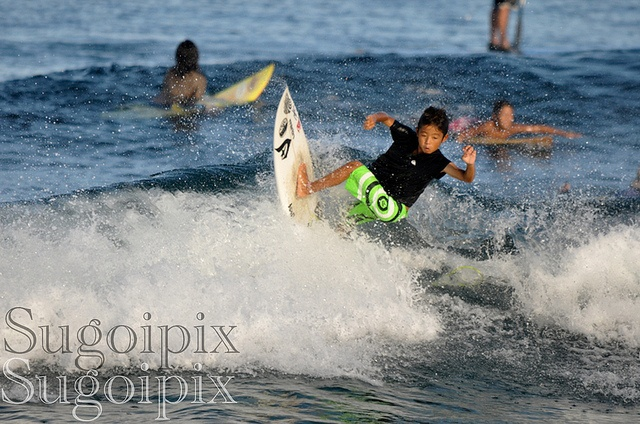Describe the objects in this image and their specific colors. I can see people in gray, black, brown, salmon, and lightgreen tones, surfboard in gray, beige, tan, and darkgray tones, surfboard in gray, darkgray, and tan tones, people in gray, brown, and black tones, and people in gray, black, and maroon tones in this image. 